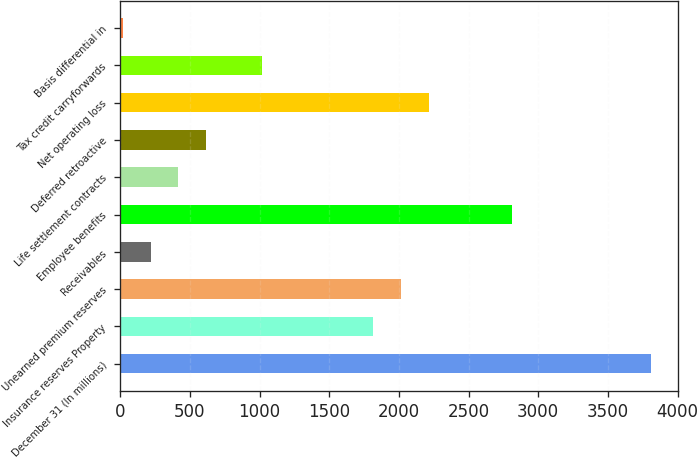<chart> <loc_0><loc_0><loc_500><loc_500><bar_chart><fcel>December 31 (In millions)<fcel>Insurance reserves Property<fcel>Unearned premium reserves<fcel>Receivables<fcel>Employee benefits<fcel>Life settlement contracts<fcel>Deferred retroactive<fcel>Net operating loss<fcel>Tax credit carryforwards<fcel>Basis differential in<nl><fcel>3811.4<fcel>1815.4<fcel>2015<fcel>218.6<fcel>2813.4<fcel>418.2<fcel>617.8<fcel>2214.6<fcel>1017<fcel>19<nl></chart> 